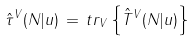<formula> <loc_0><loc_0><loc_500><loc_500>\hat { \tau } ^ { V } ( N | u ) \, = \, t r _ { V } \left \{ \hat { T } ^ { V } ( N | u ) \right \}</formula> 